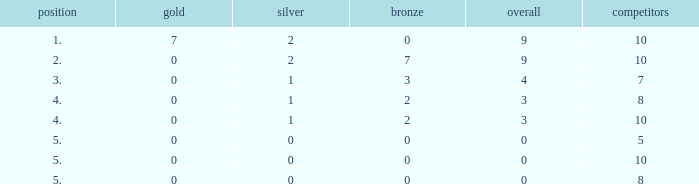What is listed as the highest Rank that has a Gold that's larger than 0, and Participants that's smaller than 10? None. 